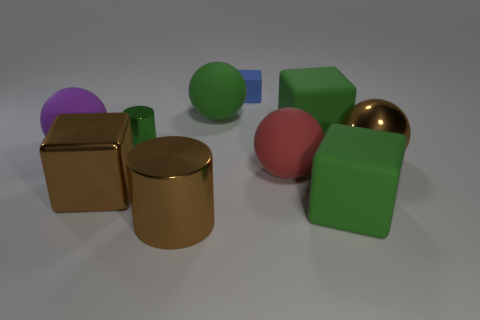There is a big cube that is the same color as the large shiny cylinder; what is it made of?
Give a very brief answer. Metal. Is the size of the brown thing in front of the brown cube the same as the tiny green shiny thing?
Keep it short and to the point. No. How many rubber things are cubes or small blocks?
Offer a terse response. 3. How many objects are in front of the large brown thing on the right side of the large red thing?
Give a very brief answer. 4. What is the shape of the big rubber thing that is behind the large brown cube and in front of the metal sphere?
Provide a short and direct response. Sphere. What is the material of the large brown thing that is to the right of the brown metal object in front of the green object in front of the big brown shiny block?
Give a very brief answer. Metal. What size is the matte sphere that is the same color as the tiny metallic thing?
Your answer should be very brief. Large. What is the big red thing made of?
Provide a succinct answer. Rubber. Do the red sphere and the big green thing on the left side of the small matte thing have the same material?
Your response must be concise. Yes. What color is the tiny thing in front of the tiny thing that is behind the small metallic cylinder?
Provide a short and direct response. Green. 